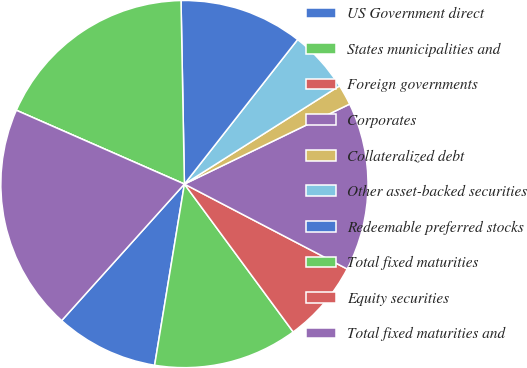Convert chart to OTSL. <chart><loc_0><loc_0><loc_500><loc_500><pie_chart><fcel>US Government direct<fcel>States municipalities and<fcel>Foreign governments<fcel>Corporates<fcel>Collateralized debt<fcel>Other asset-backed securities<fcel>Redeemable preferred stocks<fcel>Total fixed maturities<fcel>Equity securities<fcel>Total fixed maturities and<nl><fcel>9.06%<fcel>12.69%<fcel>7.25%<fcel>14.83%<fcel>1.81%<fcel>5.44%<fcel>10.87%<fcel>18.12%<fcel>0.0%<fcel>19.93%<nl></chart> 